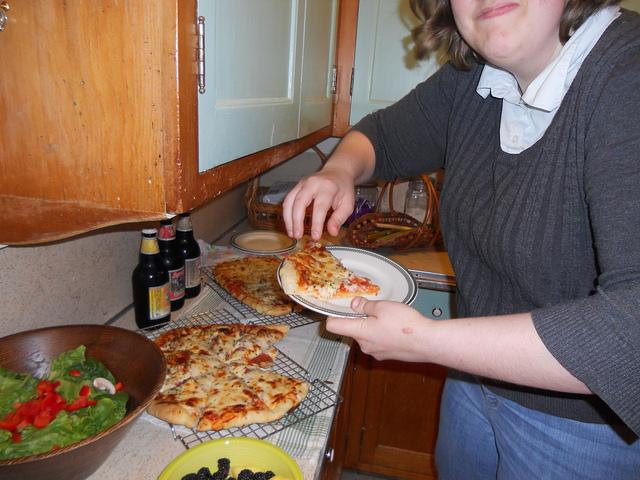What will the woman drink with her pizza? beer 